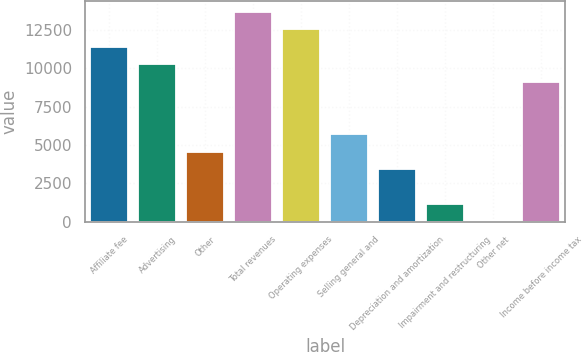Convert chart. <chart><loc_0><loc_0><loc_500><loc_500><bar_chart><fcel>Affiliate fee<fcel>Advertising<fcel>Other<fcel>Total revenues<fcel>Operating expenses<fcel>Selling general and<fcel>Depreciation and amortization<fcel>Impairment and restructuring<fcel>Other net<fcel>Income before income tax<nl><fcel>11389<fcel>10252<fcel>4567<fcel>13663<fcel>12526<fcel>5704<fcel>3430<fcel>1156<fcel>19<fcel>9115<nl></chart> 